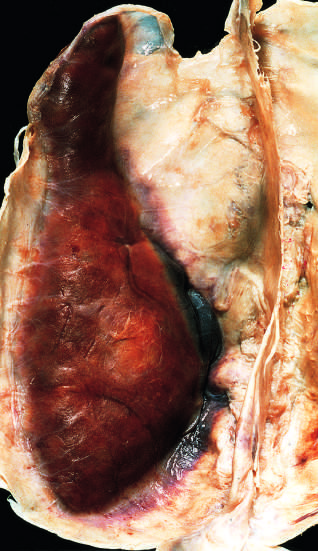s large organizing subdural hematoma attached to the dura?
Answer the question using a single word or phrase. Yes 